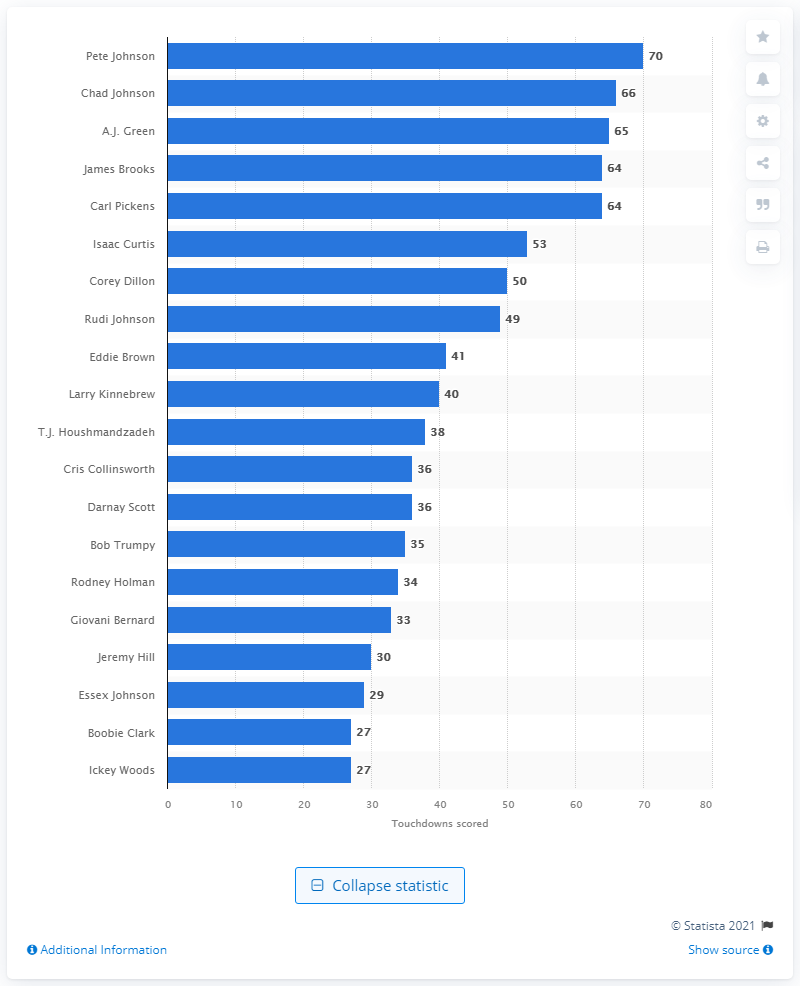Give some essential details in this illustration. Pete Johnson is the career touchdown leader of the Cincinnati Bengals. 